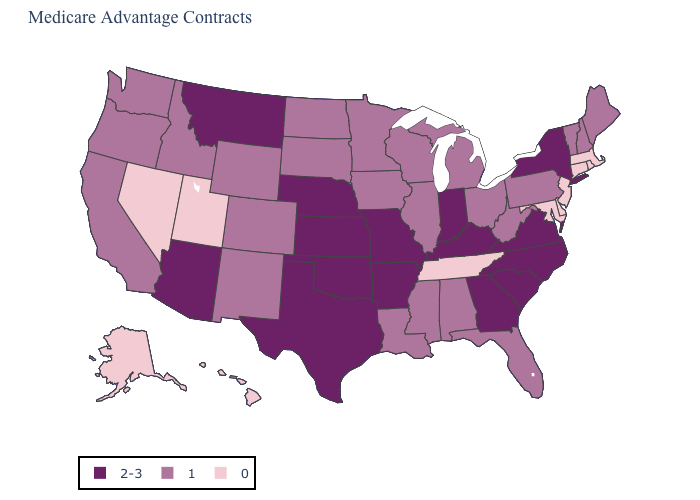Does Illinois have the same value as Louisiana?
Be succinct. Yes. What is the value of New Jersey?
Give a very brief answer. 0. What is the value of Tennessee?
Answer briefly. 0. Does Minnesota have a lower value than Indiana?
Give a very brief answer. Yes. What is the value of Michigan?
Write a very short answer. 1. Does Colorado have a lower value than Kansas?
Write a very short answer. Yes. What is the lowest value in states that border Minnesota?
Write a very short answer. 1. What is the lowest value in the MidWest?
Give a very brief answer. 1. Does Texas have the highest value in the USA?
Write a very short answer. Yes. What is the value of New Jersey?
Write a very short answer. 0. What is the value of Virginia?
Concise answer only. 2-3. Does Kentucky have the highest value in the USA?
Be succinct. Yes. What is the lowest value in the USA?
Quick response, please. 0. Which states have the lowest value in the MidWest?
Concise answer only. Iowa, Illinois, Michigan, Minnesota, North Dakota, Ohio, South Dakota, Wisconsin. Name the states that have a value in the range 2-3?
Quick response, please. Arkansas, Arizona, Georgia, Indiana, Kansas, Kentucky, Missouri, Montana, North Carolina, Nebraska, New York, Oklahoma, South Carolina, Texas, Virginia. 